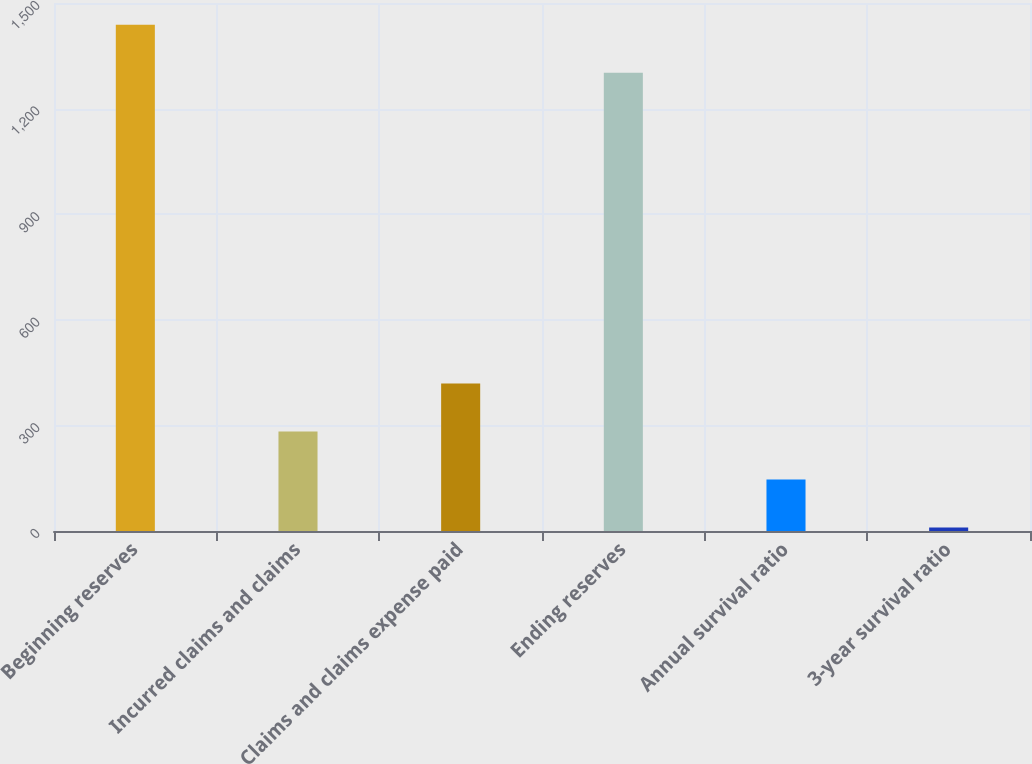<chart> <loc_0><loc_0><loc_500><loc_500><bar_chart><fcel>Beginning reserves<fcel>Incurred claims and claims<fcel>Claims and claims expense paid<fcel>Ending reserves<fcel>Annual survival ratio<fcel>3-year survival ratio<nl><fcel>1438.53<fcel>282.76<fcel>419.29<fcel>1302<fcel>146.23<fcel>9.7<nl></chart> 